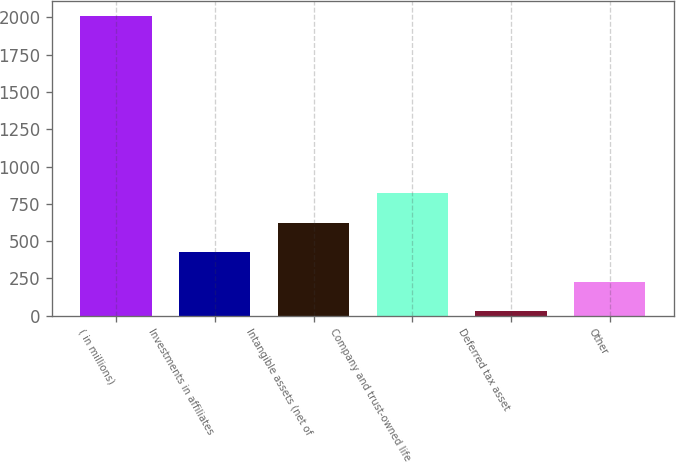Convert chart to OTSL. <chart><loc_0><loc_0><loc_500><loc_500><bar_chart><fcel>( in millions)<fcel>Investments in affiliates<fcel>Intangible assets (net of<fcel>Company and trust-owned life<fcel>Deferred tax asset<fcel>Other<nl><fcel>2009<fcel>425<fcel>623<fcel>821<fcel>29<fcel>227<nl></chart> 